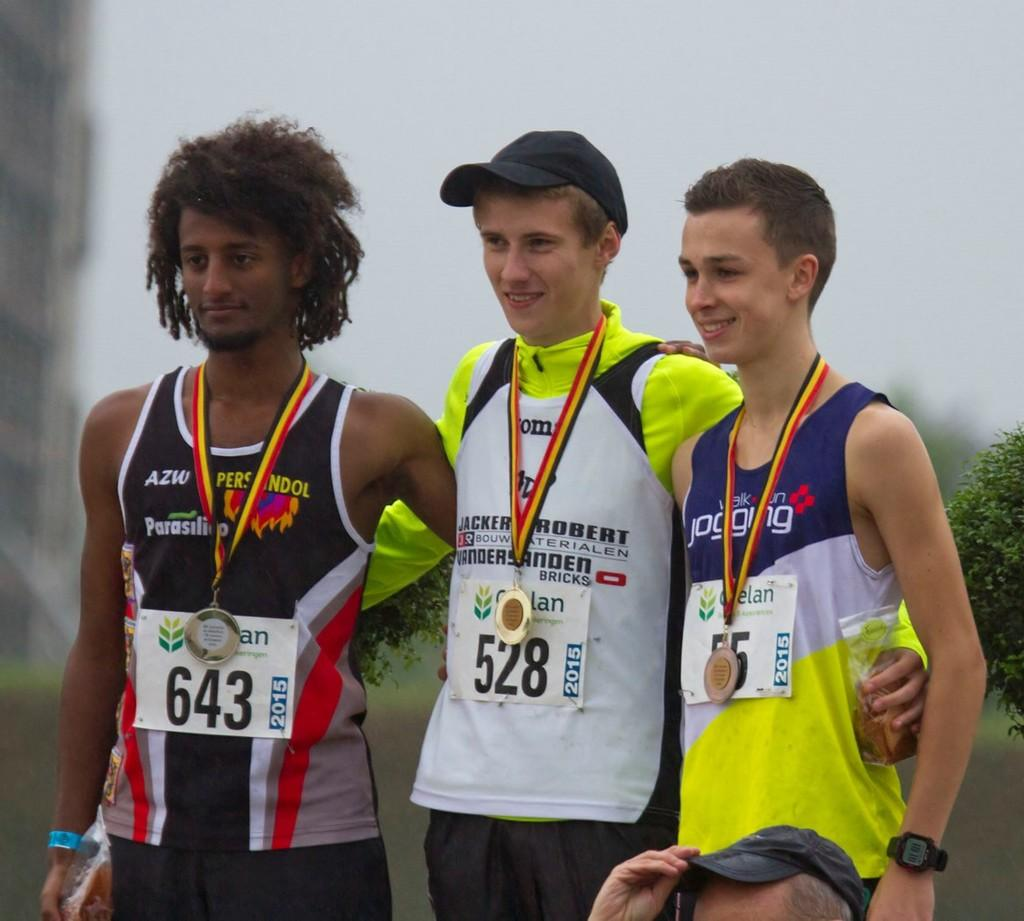<image>
Provide a brief description of the given image. The boy in the bib with the number 528 won the gold medal. 